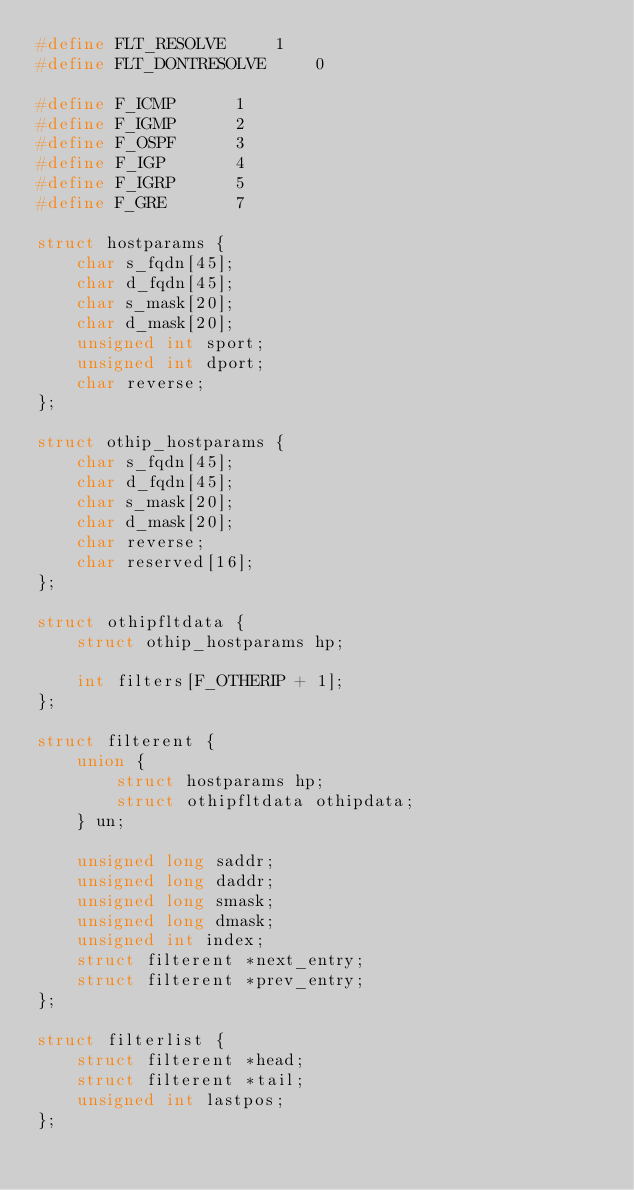Convert code to text. <code><loc_0><loc_0><loc_500><loc_500><_C_>#define FLT_RESOLVE		1
#define FLT_DONTRESOLVE		0

#define F_ICMP		1
#define F_IGMP		2
#define F_OSPF		3
#define F_IGP		4
#define F_IGRP		5
#define F_GRE		7

struct hostparams {
    char s_fqdn[45];
    char d_fqdn[45];
    char s_mask[20];
    char d_mask[20];
    unsigned int sport;
    unsigned int dport;
    char reverse;
};

struct othip_hostparams {
    char s_fqdn[45];
    char d_fqdn[45];
    char s_mask[20];
    char d_mask[20];
    char reverse;
    char reserved[16];
};

struct othipfltdata {
    struct othip_hostparams hp;
    
    int filters[F_OTHERIP + 1];
};

struct filterent {
    union {
        struct hostparams hp;
        struct othipfltdata othipdata;
    } un;
    
    unsigned long saddr;
    unsigned long daddr;
    unsigned long smask;
    unsigned long dmask;
    unsigned int index;
    struct filterent *next_entry;
    struct filterent *prev_entry;
};

struct filterlist {
    struct filterent *head;
    struct filterent *tail;
    unsigned int lastpos;
};
</code> 